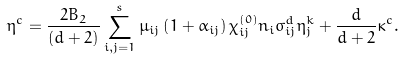<formula> <loc_0><loc_0><loc_500><loc_500>\eta ^ { c } = \frac { 2 B _ { 2 } } { \left ( d + 2 \right ) } \sum _ { i , j = 1 } ^ { s } \mu _ { i j } \left ( 1 + \alpha _ { i j } \right ) \chi _ { i j } ^ { ( 0 ) } n _ { i } \sigma _ { i j } ^ { d } \eta _ { j } ^ { k } + \frac { d } { d + 2 } \kappa ^ { c } .</formula> 